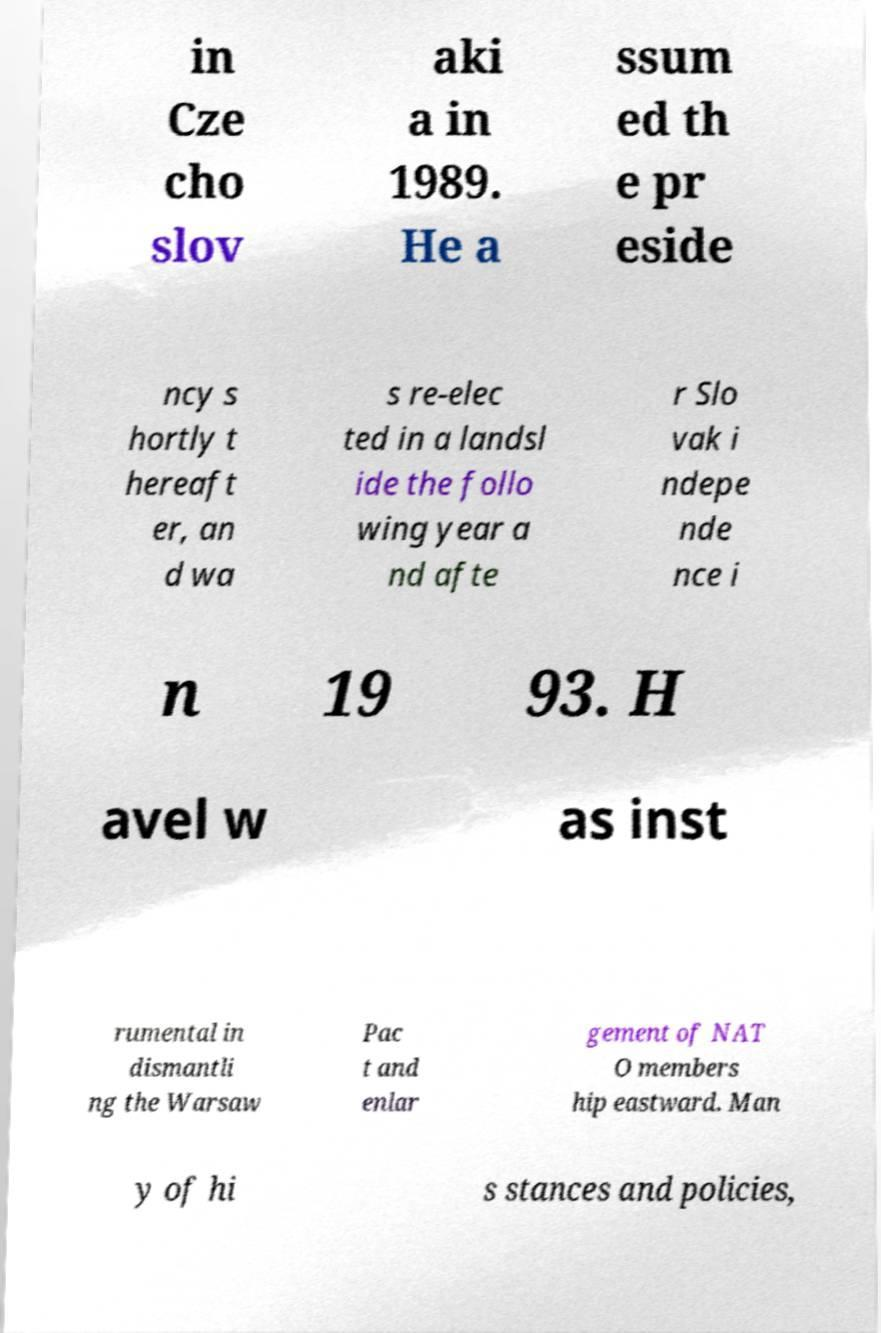For documentation purposes, I need the text within this image transcribed. Could you provide that? in Cze cho slov aki a in 1989. He a ssum ed th e pr eside ncy s hortly t hereaft er, an d wa s re-elec ted in a landsl ide the follo wing year a nd afte r Slo vak i ndepe nde nce i n 19 93. H avel w as inst rumental in dismantli ng the Warsaw Pac t and enlar gement of NAT O members hip eastward. Man y of hi s stances and policies, 